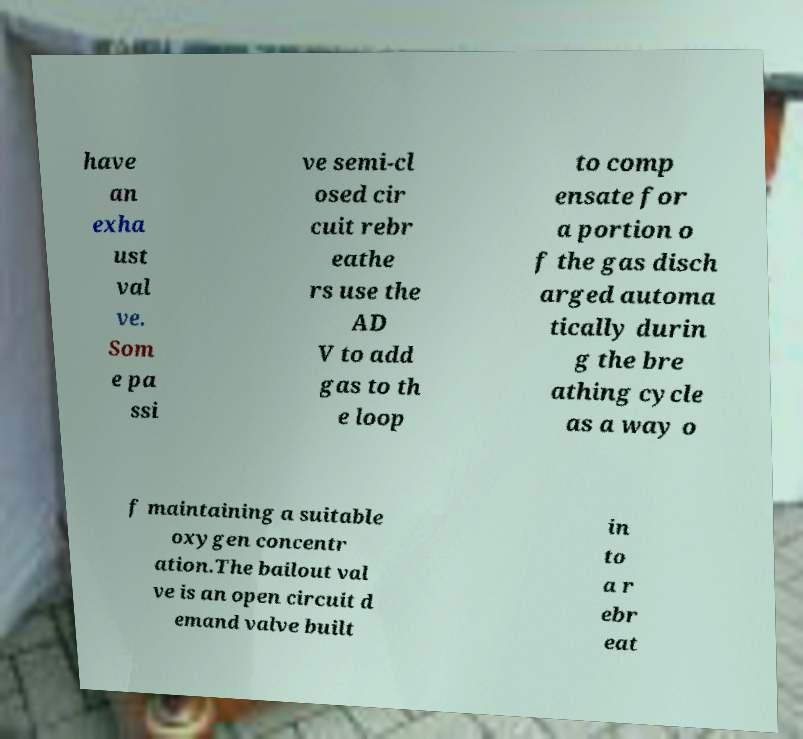What messages or text are displayed in this image? I need them in a readable, typed format. have an exha ust val ve. Som e pa ssi ve semi-cl osed cir cuit rebr eathe rs use the AD V to add gas to th e loop to comp ensate for a portion o f the gas disch arged automa tically durin g the bre athing cycle as a way o f maintaining a suitable oxygen concentr ation.The bailout val ve is an open circuit d emand valve built in to a r ebr eat 